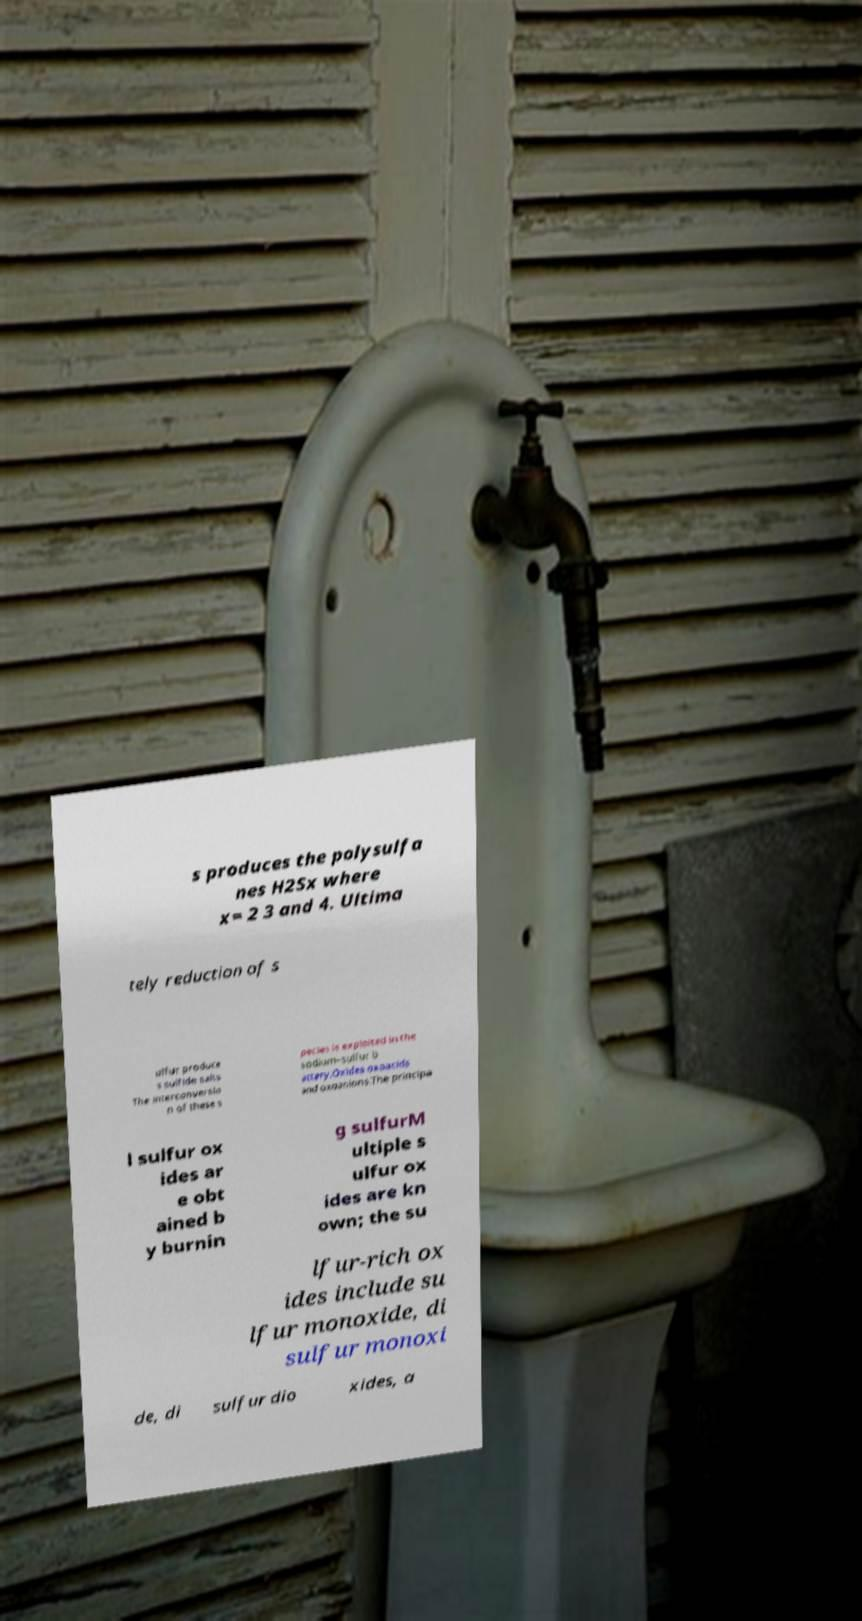I need the written content from this picture converted into text. Can you do that? s produces the polysulfa nes H2Sx where x= 2 3 and 4. Ultima tely reduction of s ulfur produce s sulfide salts The interconversio n of these s pecies is exploited in the sodium–sulfur b attery.Oxides oxoacids and oxoanions.The principa l sulfur ox ides ar e obt ained b y burnin g sulfurM ultiple s ulfur ox ides are kn own; the su lfur-rich ox ides include su lfur monoxide, di sulfur monoxi de, di sulfur dio xides, a 